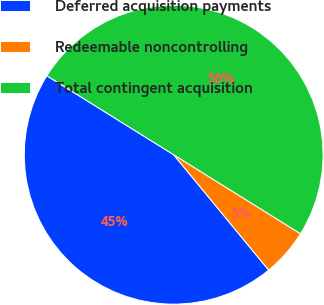Convert chart. <chart><loc_0><loc_0><loc_500><loc_500><pie_chart><fcel>Deferred acquisition payments<fcel>Redeemable noncontrolling<fcel>Total contingent acquisition<nl><fcel>44.83%<fcel>5.17%<fcel>50.0%<nl></chart> 